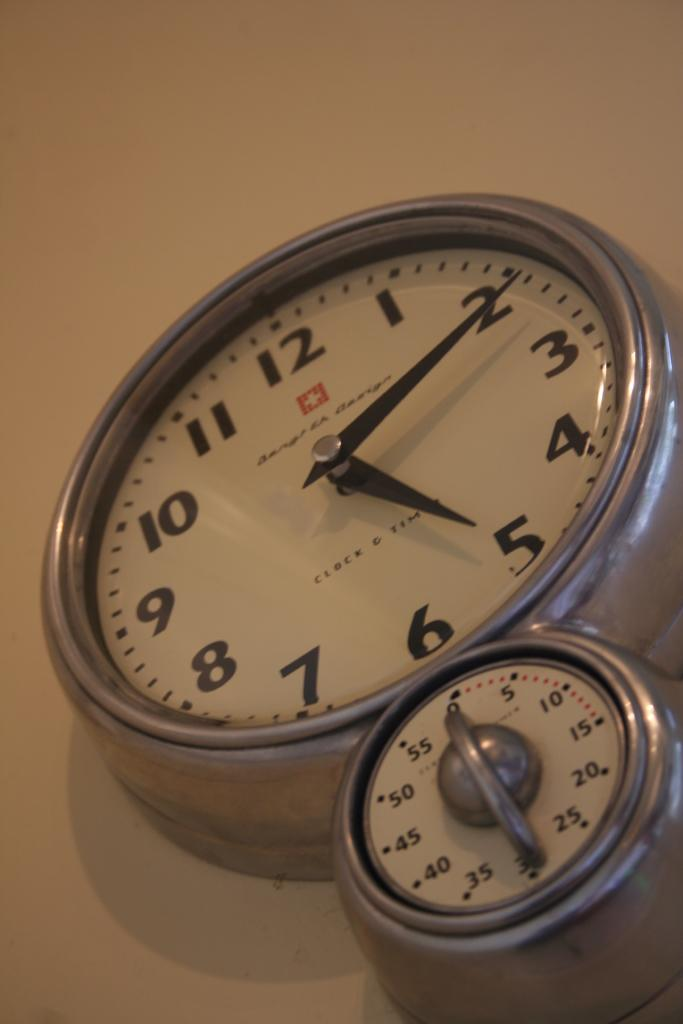What object is hanging on the wall in the image? There is a clock on the wall in the image. What might the clock be used for? The clock could be used for telling time. What is the primary function of a clock? The primary function of a clock is to measure and display time. What type of arch can be seen supporting the glass in the image? There is no arch or glass present in the image; it only features a clock on the wall. 